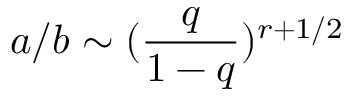<formula> <loc_0><loc_0><loc_500><loc_500>a / b \sim ( \frac { q } { 1 - q } ) ^ { r + 1 / 2 }</formula> 